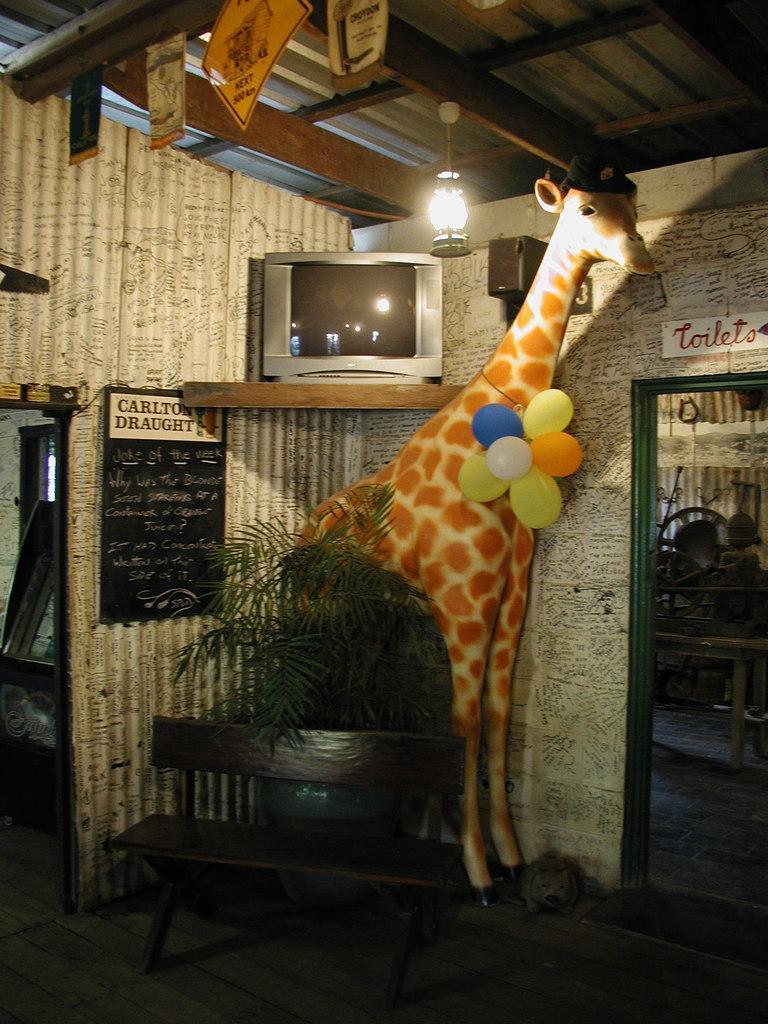Please provide a concise description of this image. In the image we can see there is a statue of giraffe standing and there are balloons which are tied to the neck of giraffe statue. The television is kept on the rack and there is a blackboard on the wall. In front there is a bench kept on the ground. 